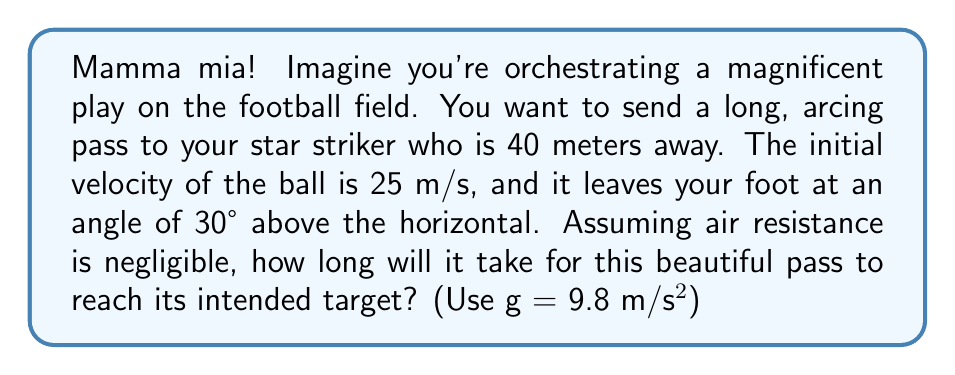Could you help me with this problem? Let's break this down step by step, just like we break down the opponent's defense!

1) First, we need to recognize that this is a projectile motion problem. The ball's path will form a parabola, which can be described by a second-order equation.

2) We'll focus on the horizontal motion, as it's not affected by gravity and will determine the time of flight. The horizontal distance is given by:

   $$x = v_0 \cos(\theta) \cdot t$$

   Where $x$ is the horizontal distance, $v_0$ is the initial velocity, $\theta$ is the launch angle, and $t$ is the time.

3) We know:
   $x = 40$ m
   $v_0 = 25$ m/s
   $\theta = 30°$

4) Substituting these values:

   $$40 = 25 \cos(30°) \cdot t$$

5) Now, let's solve for $t$:

   $$t = \frac{40}{25 \cos(30°)}$$

6) $\cos(30°) = \frac{\sqrt{3}}{2}$, so:

   $$t = \frac{40}{25 \cdot \frac{\sqrt{3}}{2}} = \frac{80}{25\sqrt{3}}$$

7) Simplifying:

   $$t = \frac{80\sqrt{3}}{75} \approx 1.85 \text{ seconds}$$

This is the time it takes for our magnificent pass to reach its target!
Answer: $t = \frac{80\sqrt{3}}{75} \approx 1.85 \text{ seconds}$ 